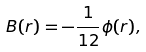<formula> <loc_0><loc_0><loc_500><loc_500>B ( r ) = - \frac { 1 } { 1 2 } \phi ( r ) ,</formula> 